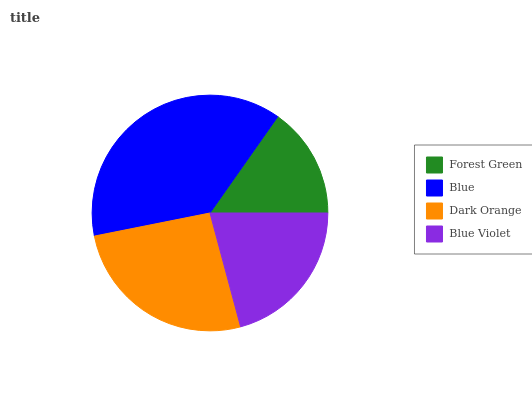Is Forest Green the minimum?
Answer yes or no. Yes. Is Blue the maximum?
Answer yes or no. Yes. Is Dark Orange the minimum?
Answer yes or no. No. Is Dark Orange the maximum?
Answer yes or no. No. Is Blue greater than Dark Orange?
Answer yes or no. Yes. Is Dark Orange less than Blue?
Answer yes or no. Yes. Is Dark Orange greater than Blue?
Answer yes or no. No. Is Blue less than Dark Orange?
Answer yes or no. No. Is Dark Orange the high median?
Answer yes or no. Yes. Is Blue Violet the low median?
Answer yes or no. Yes. Is Blue Violet the high median?
Answer yes or no. No. Is Forest Green the low median?
Answer yes or no. No. 